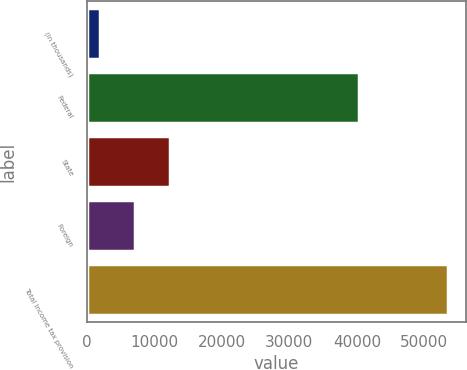Convert chart to OTSL. <chart><loc_0><loc_0><loc_500><loc_500><bar_chart><fcel>(in thousands)<fcel>Federal<fcel>State<fcel>Foreign<fcel>Total income tax provision<nl><fcel>2010<fcel>40250<fcel>12316.6<fcel>7163.3<fcel>53543<nl></chart> 